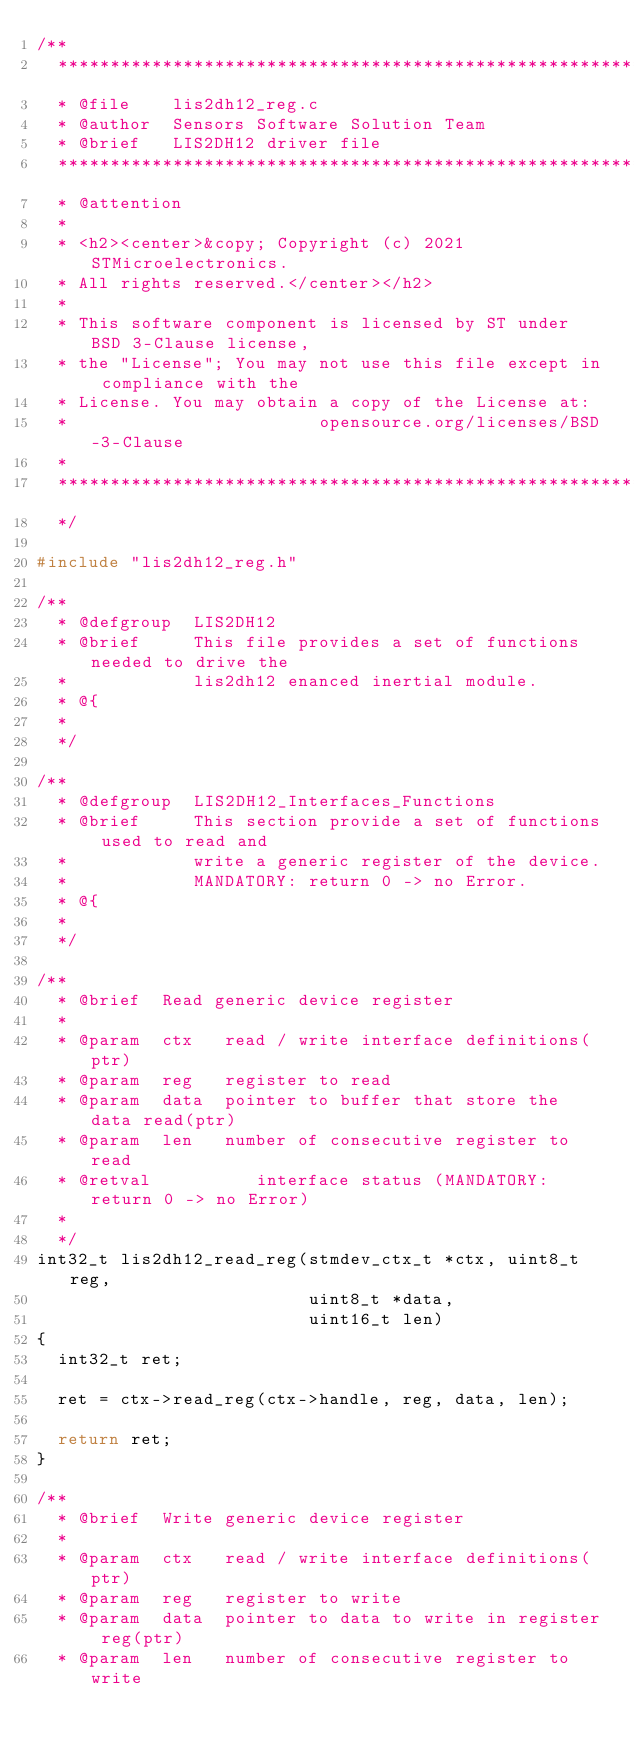Convert code to text. <code><loc_0><loc_0><loc_500><loc_500><_C_>/**
  ******************************************************************************
  * @file    lis2dh12_reg.c
  * @author  Sensors Software Solution Team
  * @brief   LIS2DH12 driver file
  ******************************************************************************
  * @attention
  *
  * <h2><center>&copy; Copyright (c) 2021 STMicroelectronics.
  * All rights reserved.</center></h2>
  *
  * This software component is licensed by ST under BSD 3-Clause license,
  * the "License"; You may not use this file except in compliance with the
  * License. You may obtain a copy of the License at:
  *                        opensource.org/licenses/BSD-3-Clause
  *
  ******************************************************************************
  */

#include "lis2dh12_reg.h"

/**
  * @defgroup  LIS2DH12
  * @brief     This file provides a set of functions needed to drive the
  *            lis2dh12 enanced inertial module.
  * @{
  *
  */

/**
  * @defgroup  LIS2DH12_Interfaces_Functions
  * @brief     This section provide a set of functions used to read and
  *            write a generic register of the device.
  *            MANDATORY: return 0 -> no Error.
  * @{
  *
  */

/**
  * @brief  Read generic device register
  *
  * @param  ctx   read / write interface definitions(ptr)
  * @param  reg   register to read
  * @param  data  pointer to buffer that store the data read(ptr)
  * @param  len   number of consecutive register to read
  * @retval          interface status (MANDATORY: return 0 -> no Error)
  *
  */
int32_t lis2dh12_read_reg(stmdev_ctx_t *ctx, uint8_t reg,
                          uint8_t *data,
                          uint16_t len)
{
  int32_t ret;

  ret = ctx->read_reg(ctx->handle, reg, data, len);

  return ret;
}

/**
  * @brief  Write generic device register
  *
  * @param  ctx   read / write interface definitions(ptr)
  * @param  reg   register to write
  * @param  data  pointer to data to write in register reg(ptr)
  * @param  len   number of consecutive register to write</code> 